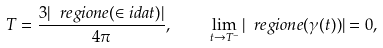<formula> <loc_0><loc_0><loc_500><loc_500>T = \frac { 3 | \ r e g i o n e ( \in i d a t ) | } { 4 \pi } , \quad \lim _ { t \to T ^ { - } } | \ r e g i o n e ( \gamma ( t ) ) | = 0 ,</formula> 